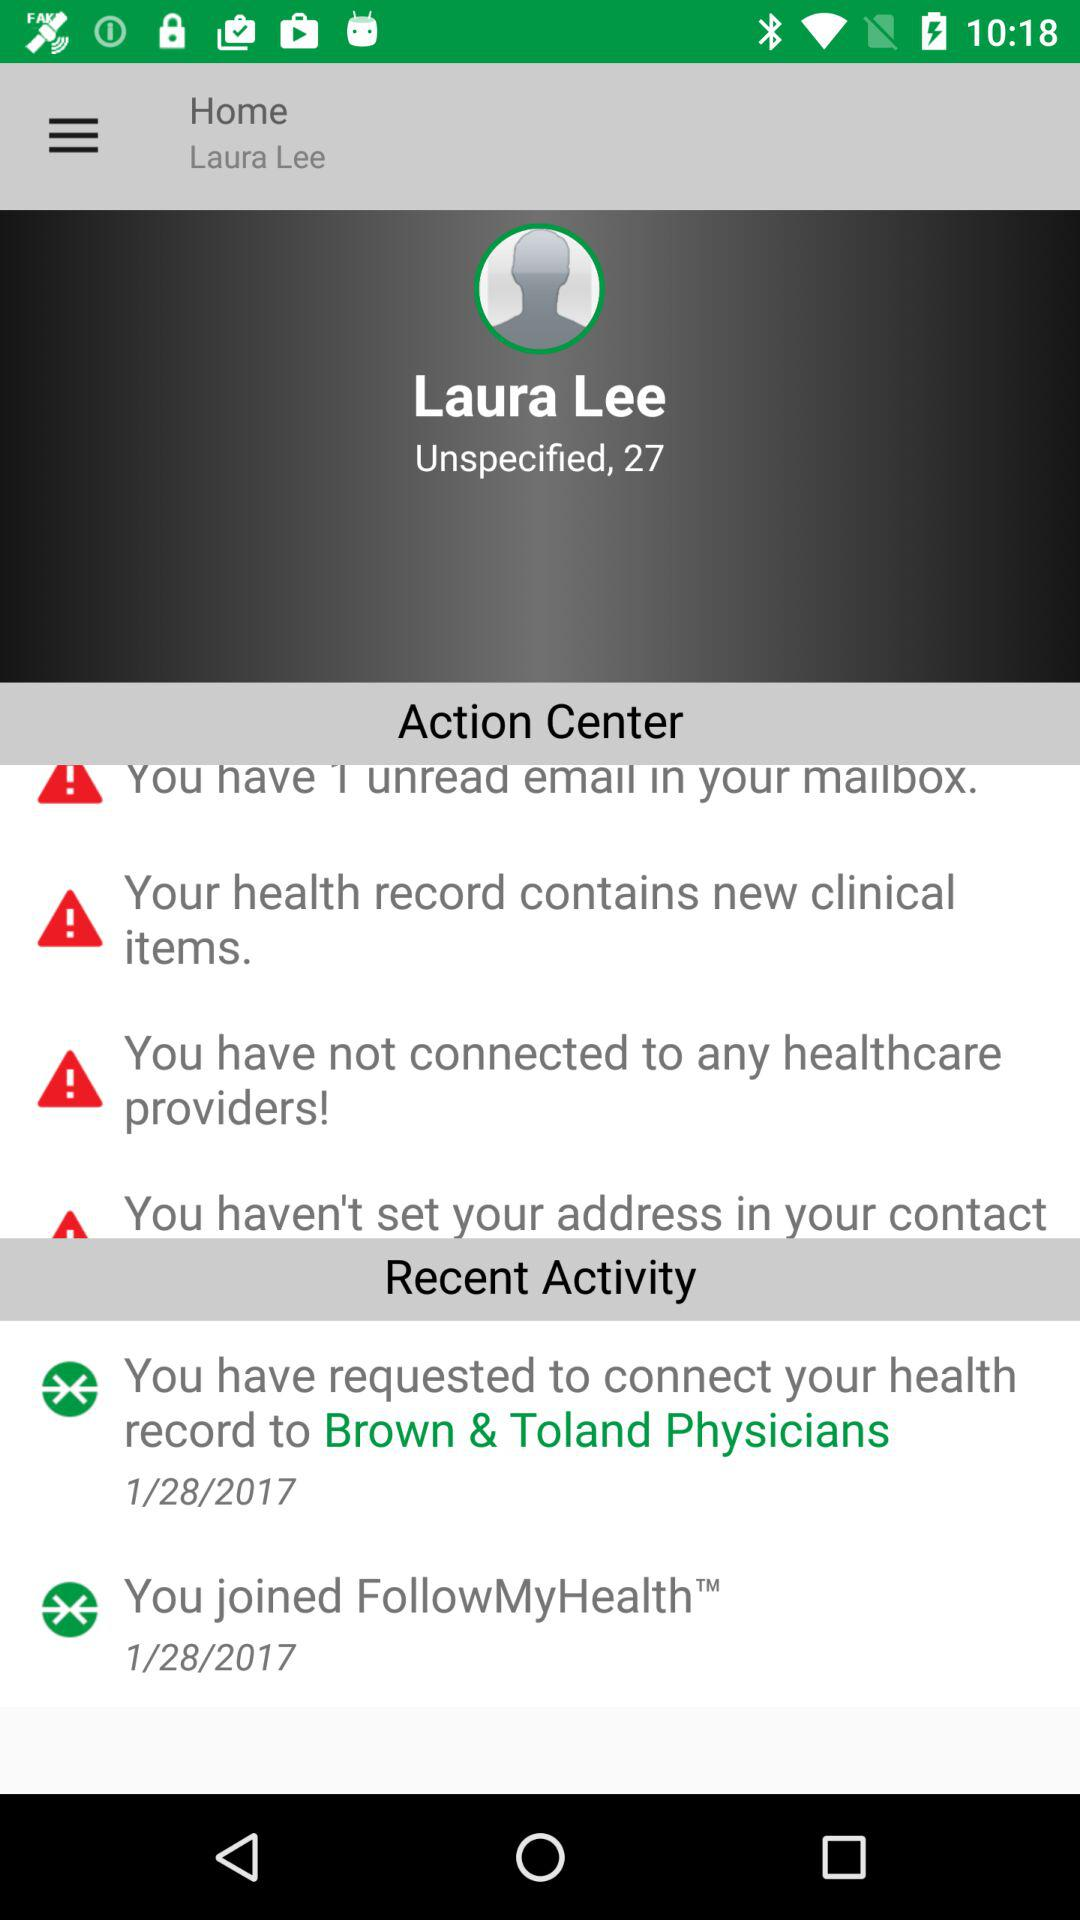What are the notifications in "Action Center"? The notifications are "You have 1 unread email in your mailbox.", "Your health record contains new clinical items." and "You have not connected to any healthcare providers!". 